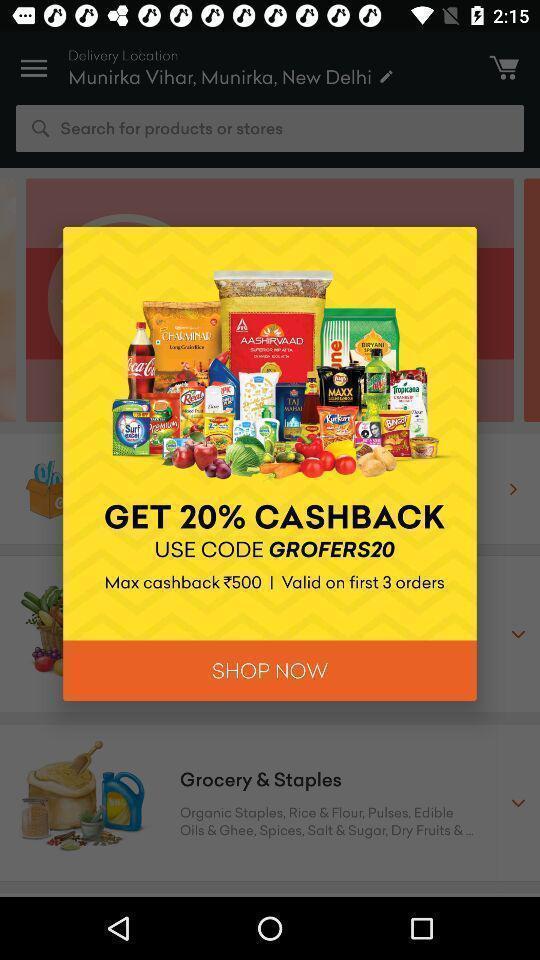Please provide a description for this image. Pop-up asking to shop the grocery using the code. 